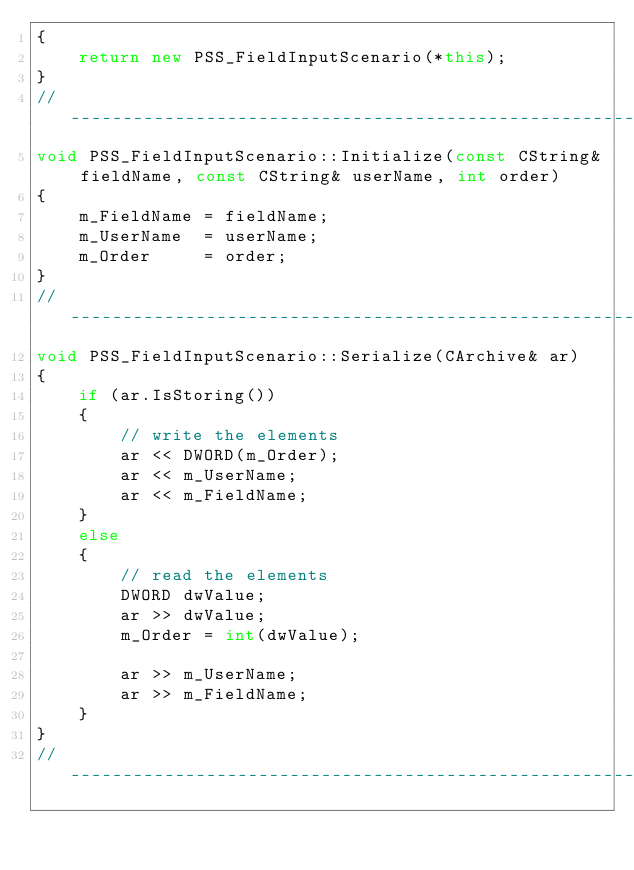<code> <loc_0><loc_0><loc_500><loc_500><_C++_>{
    return new PSS_FieldInputScenario(*this);
}
//---------------------------------------------------------------------------
void PSS_FieldInputScenario::Initialize(const CString& fieldName, const CString& userName, int order)
{
    m_FieldName = fieldName;
    m_UserName  = userName;
    m_Order     = order;
}
//---------------------------------------------------------------------------
void PSS_FieldInputScenario::Serialize(CArchive& ar)
{
    if (ar.IsStoring())
    {
        // write the elements
        ar << DWORD(m_Order);
        ar << m_UserName;
        ar << m_FieldName;
    }
    else
    {
        // read the elements
        DWORD dwValue;
        ar >> dwValue;
        m_Order = int(dwValue);

        ar >> m_UserName;
        ar >> m_FieldName;
    }
}
//---------------------------------------------------------------------------
</code> 